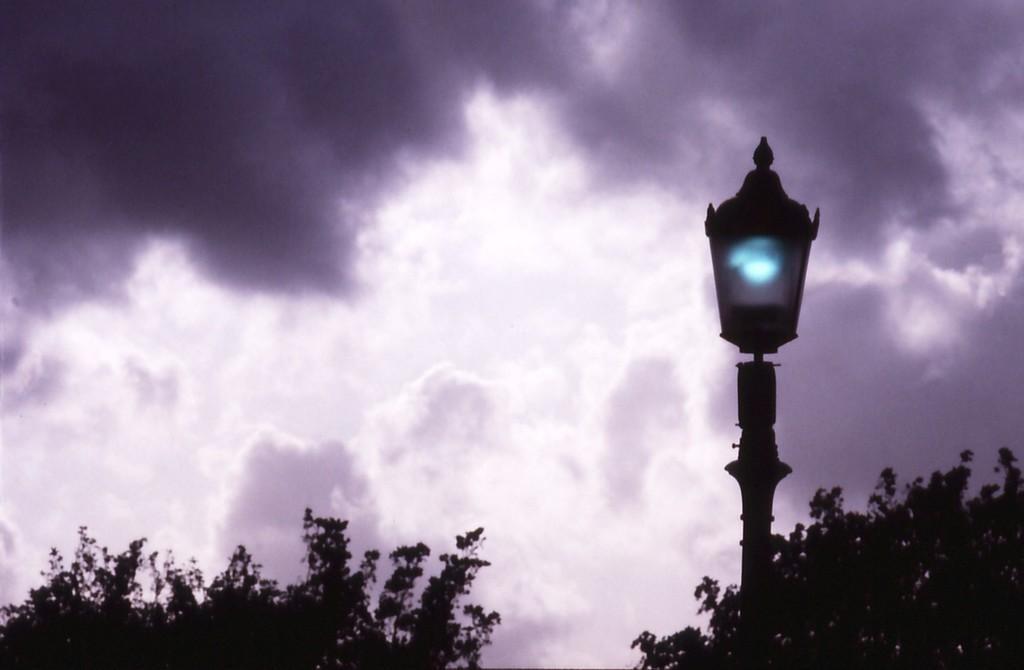Describe this image in one or two sentences. This image consists of clouds in the sky. At the bottom, there are trees. In the middle, there is a pole along with a light. 